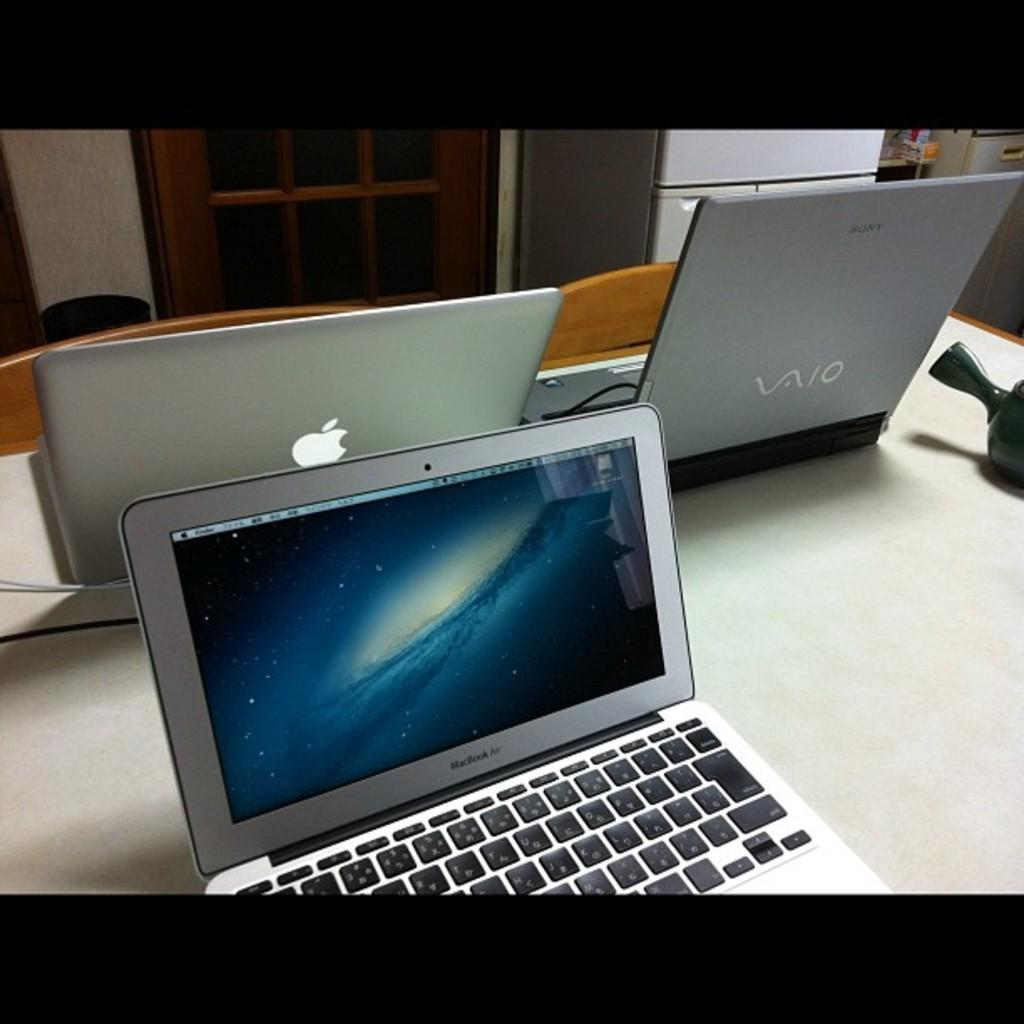<image>
Describe the image concisely. A grey Sony laptop sits near two grey Macbooks 